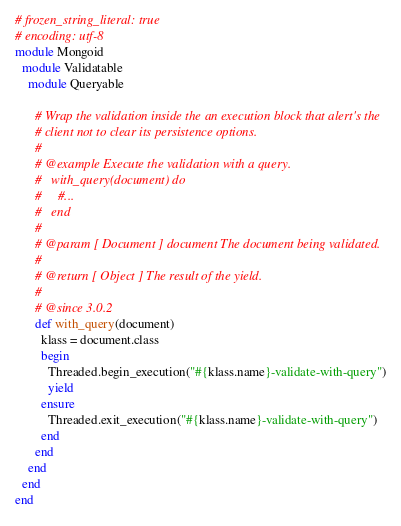Convert code to text. <code><loc_0><loc_0><loc_500><loc_500><_Ruby_># frozen_string_literal: true
# encoding: utf-8
module Mongoid
  module Validatable
    module Queryable

      # Wrap the validation inside the an execution block that alert's the
      # client not to clear its persistence options.
      #
      # @example Execute the validation with a query.
      #   with_query(document) do
      #     #...
      #   end
      #
      # @param [ Document ] document The document being validated.
      #
      # @return [ Object ] The result of the yield.
      #
      # @since 3.0.2
      def with_query(document)
        klass = document.class
        begin
          Threaded.begin_execution("#{klass.name}-validate-with-query")
          yield
        ensure
          Threaded.exit_execution("#{klass.name}-validate-with-query")
        end
      end
    end
  end
end
</code> 